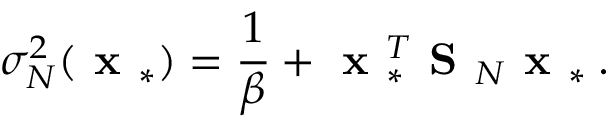Convert formula to latex. <formula><loc_0><loc_0><loc_500><loc_500>\sigma _ { N } ^ { 2 } ( x _ { * } ) = \frac { 1 } { \beta } + x _ { * } ^ { T } S _ { N } x _ { * } \, .</formula> 